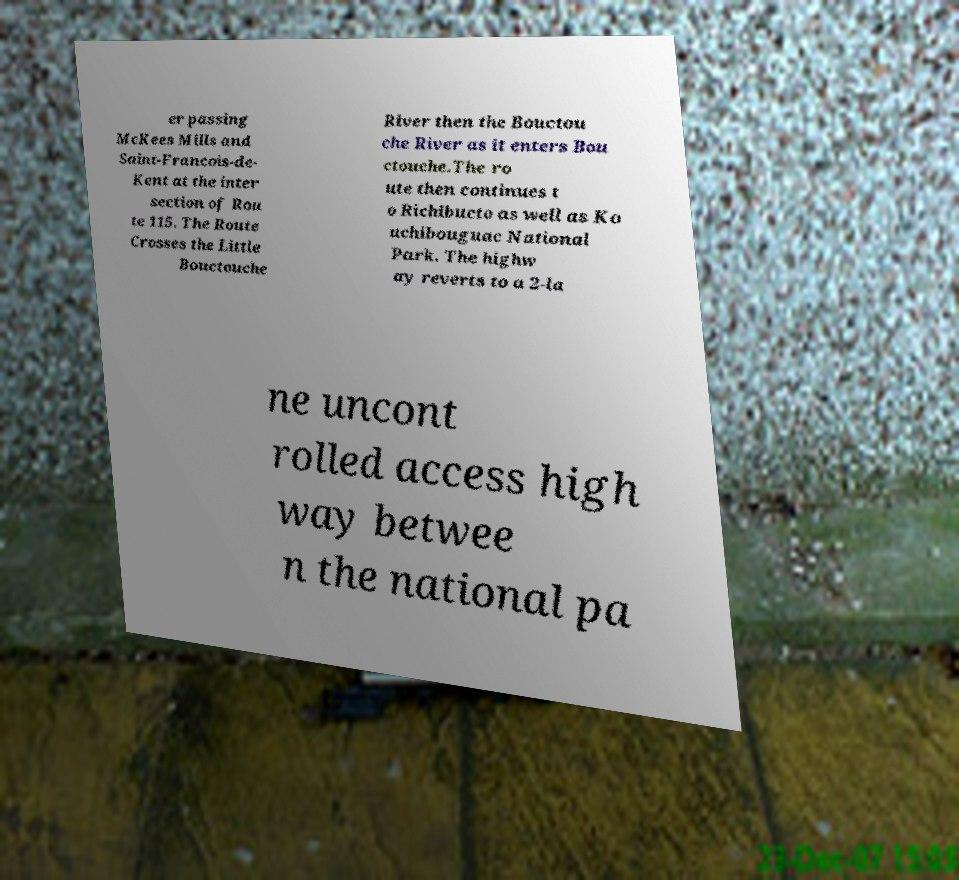Could you extract and type out the text from this image? er passing McKees Mills and Saint-Francois-de- Kent at the inter section of Rou te 115. The Route Crosses the Little Bouctouche River then the Bouctou che River as it enters Bou ctouche.The ro ute then continues t o Richibucto as well as Ko uchibouguac National Park. The highw ay reverts to a 2-la ne uncont rolled access high way betwee n the national pa 